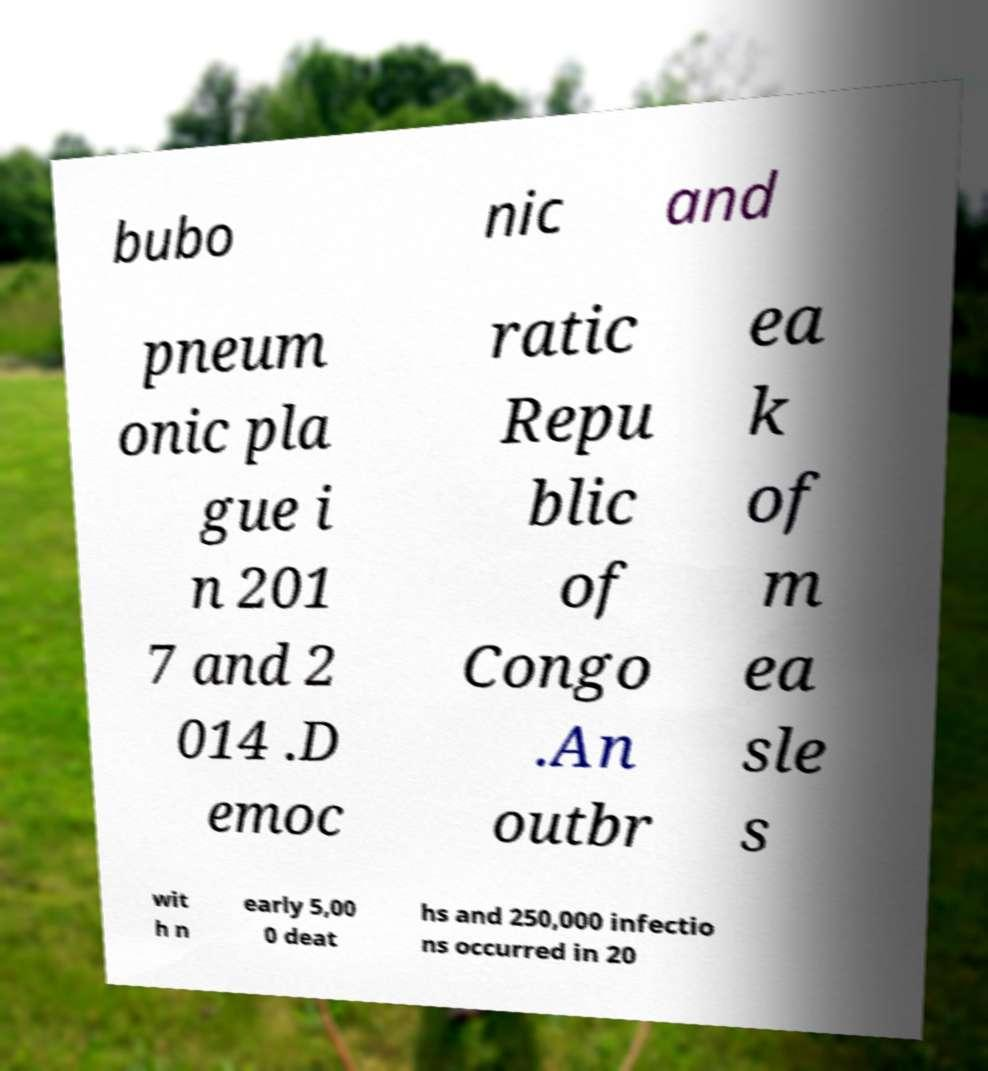There's text embedded in this image that I need extracted. Can you transcribe it verbatim? bubo nic and pneum onic pla gue i n 201 7 and 2 014 .D emoc ratic Repu blic of Congo .An outbr ea k of m ea sle s wit h n early 5,00 0 deat hs and 250,000 infectio ns occurred in 20 